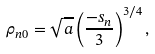<formula> <loc_0><loc_0><loc_500><loc_500>\rho _ { n 0 } = \sqrt { a } \left ( \frac { - s _ { n } } { 3 } \right ) ^ { 3 / 4 } ,</formula> 